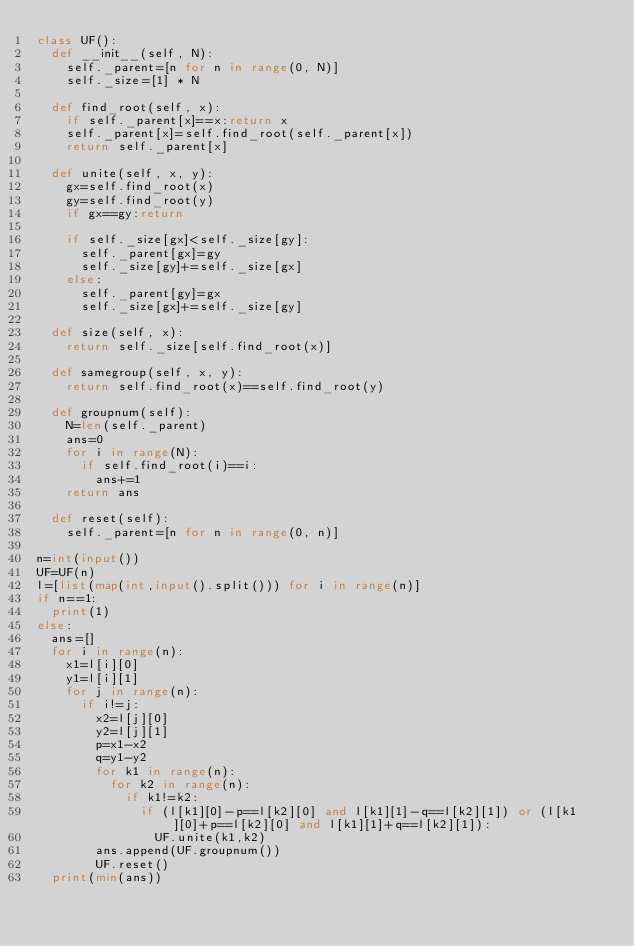<code> <loc_0><loc_0><loc_500><loc_500><_Python_>class UF():
  def __init__(self, N):
    self._parent=[n for n in range(0, N)]
    self._size=[1] * N

  def find_root(self, x):
    if self._parent[x]==x:return x
    self._parent[x]=self.find_root(self._parent[x])
    return self._parent[x]

  def unite(self, x, y):
    gx=self.find_root(x)
    gy=self.find_root(y)
    if gx==gy:return

    if self._size[gx]<self._size[gy]:
      self._parent[gx]=gy
      self._size[gy]+=self._size[gx]
    else:
      self._parent[gy]=gx
      self._size[gx]+=self._size[gy]

  def size(self, x):
    return self._size[self.find_root(x)]

  def samegroup(self, x, y):
    return self.find_root(x)==self.find_root(y)

  def groupnum(self):
    N=len(self._parent)
    ans=0
    for i in range(N):
      if self.find_root(i)==i:
        ans+=1
    return ans

  def reset(self):
    self._parent=[n for n in range(0, n)]

n=int(input())
UF=UF(n)
l=[list(map(int,input().split())) for i in range(n)]
if n==1:
  print(1)
else:
  ans=[]
  for i in range(n):
    x1=l[i][0]
    y1=l[i][1]
    for j in range(n):
      if i!=j:
        x2=l[j][0]
        y2=l[j][1]
        p=x1-x2
        q=y1-y2
        for k1 in range(n):
          for k2 in range(n):
            if k1!=k2:
              if (l[k1][0]-p==l[k2][0] and l[k1][1]-q==l[k2][1]) or (l[k1][0]+p==l[k2][0] and l[k1][1]+q==l[k2][1]):
                UF.unite(k1,k2)
        ans.append(UF.groupnum())
        UF.reset()
  print(min(ans))</code> 